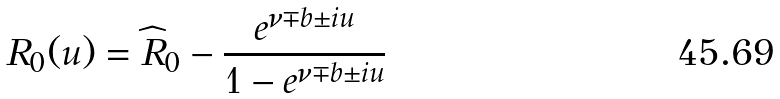<formula> <loc_0><loc_0><loc_500><loc_500>R _ { 0 } ( u ) = \widehat { R } _ { 0 } - \frac { e ^ { \nu \mp b \pm i u } } { 1 - e ^ { \nu \mp b \pm i u } }</formula> 